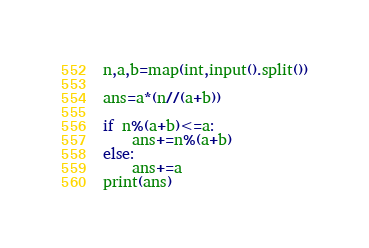<code> <loc_0><loc_0><loc_500><loc_500><_Python_>n,a,b=map(int,input().split())

ans=a*(n//(a+b))

if n%(a+b)<=a:
    ans+=n%(a+b)
else:
    ans+=a
print(ans)
</code> 